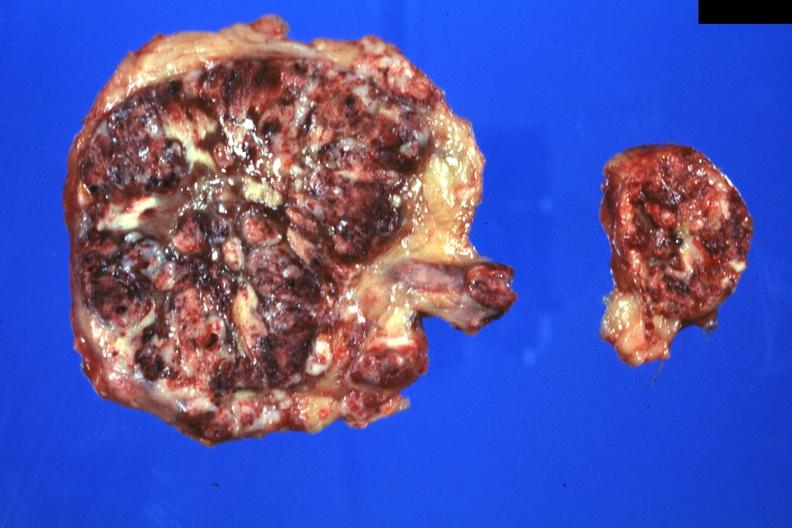does this image show massive replacement can not see any adrenal tissue?
Answer the question using a single word or phrase. Yes 